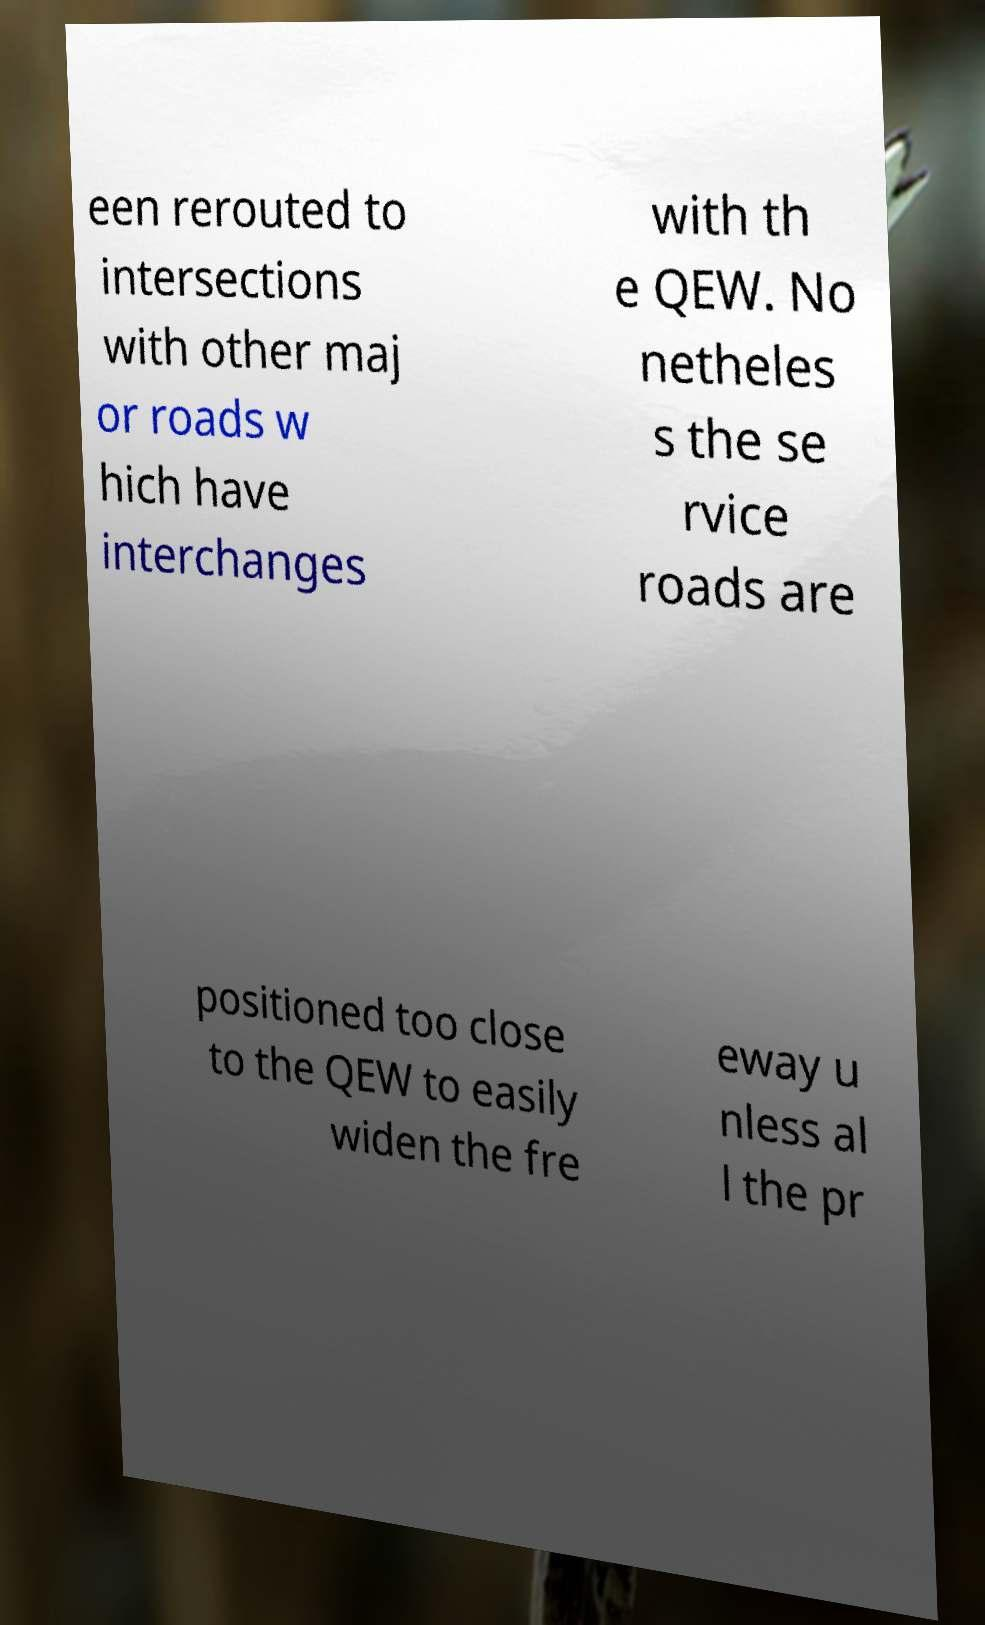I need the written content from this picture converted into text. Can you do that? een rerouted to intersections with other maj or roads w hich have interchanges with th e QEW. No netheles s the se rvice roads are positioned too close to the QEW to easily widen the fre eway u nless al l the pr 